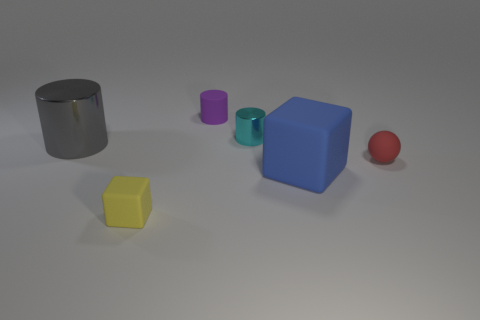What number of other things are there of the same size as the purple matte object?
Make the answer very short. 3. Do the sphere and the small rubber block have the same color?
Provide a short and direct response. No. What shape is the metallic object behind the shiny object on the left side of the small rubber object in front of the red ball?
Give a very brief answer. Cylinder. What number of objects are either objects in front of the red matte thing or things right of the large gray cylinder?
Keep it short and to the point. 5. What is the size of the block right of the small cylinder in front of the tiny matte cylinder?
Provide a short and direct response. Large. Do the big thing to the right of the purple cylinder and the tiny sphere have the same color?
Make the answer very short. No. Is there a gray object of the same shape as the cyan object?
Ensure brevity in your answer.  Yes. The rubber cylinder that is the same size as the red sphere is what color?
Your answer should be compact. Purple. How big is the matte block that is behind the yellow object?
Offer a very short reply. Large. Are there any big gray objects that are behind the tiny matte thing that is in front of the tiny red rubber ball?
Ensure brevity in your answer.  Yes. 